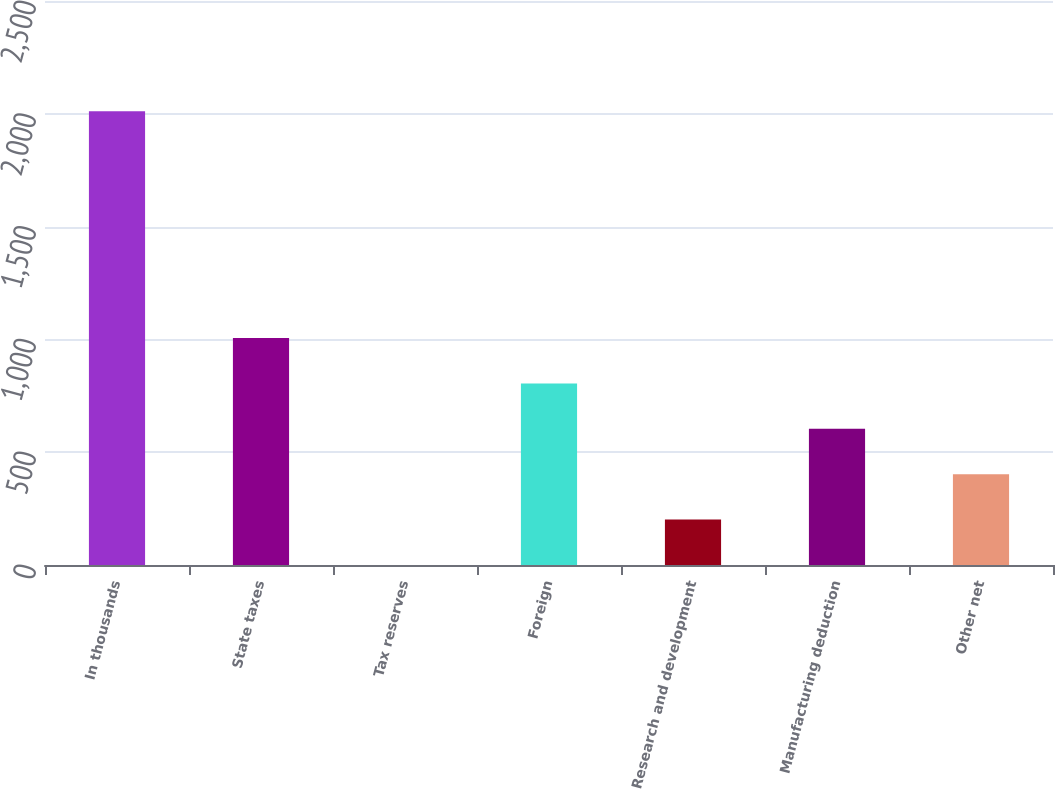Convert chart. <chart><loc_0><loc_0><loc_500><loc_500><bar_chart><fcel>In thousands<fcel>State taxes<fcel>Tax reserves<fcel>Foreign<fcel>Research and development<fcel>Manufacturing deduction<fcel>Other net<nl><fcel>2011<fcel>1005.75<fcel>0.5<fcel>804.7<fcel>201.55<fcel>603.65<fcel>402.6<nl></chart> 